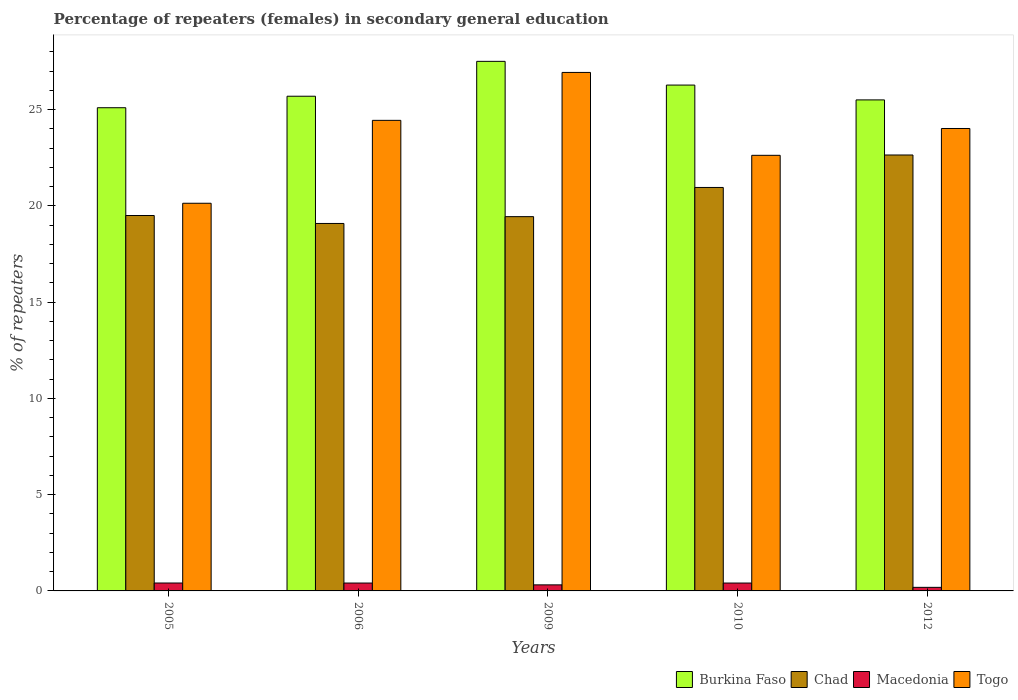How many different coloured bars are there?
Your answer should be compact. 4. How many groups of bars are there?
Give a very brief answer. 5. Are the number of bars per tick equal to the number of legend labels?
Keep it short and to the point. Yes. How many bars are there on the 3rd tick from the right?
Keep it short and to the point. 4. What is the label of the 2nd group of bars from the left?
Offer a terse response. 2006. What is the percentage of female repeaters in Macedonia in 2012?
Your answer should be compact. 0.19. Across all years, what is the maximum percentage of female repeaters in Macedonia?
Make the answer very short. 0.41. Across all years, what is the minimum percentage of female repeaters in Chad?
Provide a short and direct response. 19.09. In which year was the percentage of female repeaters in Togo maximum?
Keep it short and to the point. 2009. In which year was the percentage of female repeaters in Chad minimum?
Provide a succinct answer. 2006. What is the total percentage of female repeaters in Burkina Faso in the graph?
Your answer should be very brief. 130.07. What is the difference between the percentage of female repeaters in Macedonia in 2005 and that in 2006?
Your answer should be compact. 0. What is the difference between the percentage of female repeaters in Chad in 2010 and the percentage of female repeaters in Togo in 2009?
Provide a succinct answer. -5.98. What is the average percentage of female repeaters in Burkina Faso per year?
Provide a short and direct response. 26.01. In the year 2010, what is the difference between the percentage of female repeaters in Togo and percentage of female repeaters in Chad?
Offer a terse response. 1.67. In how many years, is the percentage of female repeaters in Chad greater than 25 %?
Your response must be concise. 0. What is the ratio of the percentage of female repeaters in Macedonia in 2005 to that in 2012?
Offer a terse response. 2.22. Is the percentage of female repeaters in Macedonia in 2009 less than that in 2010?
Offer a very short reply. Yes. Is the difference between the percentage of female repeaters in Togo in 2010 and 2012 greater than the difference between the percentage of female repeaters in Chad in 2010 and 2012?
Your answer should be compact. Yes. What is the difference between the highest and the second highest percentage of female repeaters in Chad?
Ensure brevity in your answer.  1.69. What is the difference between the highest and the lowest percentage of female repeaters in Chad?
Ensure brevity in your answer.  3.56. In how many years, is the percentage of female repeaters in Togo greater than the average percentage of female repeaters in Togo taken over all years?
Offer a terse response. 3. Is the sum of the percentage of female repeaters in Togo in 2005 and 2009 greater than the maximum percentage of female repeaters in Chad across all years?
Keep it short and to the point. Yes. Is it the case that in every year, the sum of the percentage of female repeaters in Burkina Faso and percentage of female repeaters in Macedonia is greater than the sum of percentage of female repeaters in Togo and percentage of female repeaters in Chad?
Offer a very short reply. No. What does the 3rd bar from the left in 2005 represents?
Provide a succinct answer. Macedonia. What does the 4th bar from the right in 2010 represents?
Ensure brevity in your answer.  Burkina Faso. Is it the case that in every year, the sum of the percentage of female repeaters in Togo and percentage of female repeaters in Burkina Faso is greater than the percentage of female repeaters in Macedonia?
Your response must be concise. Yes. How many years are there in the graph?
Your response must be concise. 5. Does the graph contain any zero values?
Keep it short and to the point. No. How are the legend labels stacked?
Offer a terse response. Horizontal. What is the title of the graph?
Your answer should be compact. Percentage of repeaters (females) in secondary general education. Does "East Asia (all income levels)" appear as one of the legend labels in the graph?
Keep it short and to the point. No. What is the label or title of the Y-axis?
Keep it short and to the point. % of repeaters. What is the % of repeaters of Burkina Faso in 2005?
Provide a succinct answer. 25.1. What is the % of repeaters of Chad in 2005?
Offer a terse response. 19.5. What is the % of repeaters of Macedonia in 2005?
Ensure brevity in your answer.  0.41. What is the % of repeaters of Togo in 2005?
Give a very brief answer. 20.13. What is the % of repeaters of Burkina Faso in 2006?
Offer a terse response. 25.69. What is the % of repeaters in Chad in 2006?
Keep it short and to the point. 19.09. What is the % of repeaters of Macedonia in 2006?
Keep it short and to the point. 0.41. What is the % of repeaters in Togo in 2006?
Provide a succinct answer. 24.44. What is the % of repeaters in Burkina Faso in 2009?
Make the answer very short. 27.5. What is the % of repeaters of Chad in 2009?
Your answer should be very brief. 19.44. What is the % of repeaters of Macedonia in 2009?
Offer a terse response. 0.31. What is the % of repeaters in Togo in 2009?
Offer a terse response. 26.93. What is the % of repeaters of Burkina Faso in 2010?
Provide a short and direct response. 26.27. What is the % of repeaters of Chad in 2010?
Offer a terse response. 20.95. What is the % of repeaters in Macedonia in 2010?
Ensure brevity in your answer.  0.41. What is the % of repeaters in Togo in 2010?
Make the answer very short. 22.62. What is the % of repeaters of Burkina Faso in 2012?
Provide a short and direct response. 25.5. What is the % of repeaters in Chad in 2012?
Your response must be concise. 22.64. What is the % of repeaters in Macedonia in 2012?
Offer a terse response. 0.19. What is the % of repeaters in Togo in 2012?
Offer a terse response. 24.02. Across all years, what is the maximum % of repeaters in Burkina Faso?
Make the answer very short. 27.5. Across all years, what is the maximum % of repeaters of Chad?
Your response must be concise. 22.64. Across all years, what is the maximum % of repeaters in Macedonia?
Provide a succinct answer. 0.41. Across all years, what is the maximum % of repeaters of Togo?
Make the answer very short. 26.93. Across all years, what is the minimum % of repeaters of Burkina Faso?
Offer a very short reply. 25.1. Across all years, what is the minimum % of repeaters in Chad?
Your answer should be compact. 19.09. Across all years, what is the minimum % of repeaters in Macedonia?
Give a very brief answer. 0.19. Across all years, what is the minimum % of repeaters in Togo?
Give a very brief answer. 20.13. What is the total % of repeaters in Burkina Faso in the graph?
Provide a succinct answer. 130.07. What is the total % of repeaters in Chad in the graph?
Your answer should be very brief. 101.62. What is the total % of repeaters of Macedonia in the graph?
Offer a terse response. 1.73. What is the total % of repeaters of Togo in the graph?
Provide a succinct answer. 118.15. What is the difference between the % of repeaters of Burkina Faso in 2005 and that in 2006?
Give a very brief answer. -0.6. What is the difference between the % of repeaters in Chad in 2005 and that in 2006?
Your answer should be very brief. 0.41. What is the difference between the % of repeaters of Macedonia in 2005 and that in 2006?
Give a very brief answer. 0. What is the difference between the % of repeaters of Togo in 2005 and that in 2006?
Your answer should be compact. -4.31. What is the difference between the % of repeaters of Burkina Faso in 2005 and that in 2009?
Offer a very short reply. -2.41. What is the difference between the % of repeaters of Chad in 2005 and that in 2009?
Your response must be concise. 0.06. What is the difference between the % of repeaters in Macedonia in 2005 and that in 2009?
Offer a terse response. 0.1. What is the difference between the % of repeaters in Togo in 2005 and that in 2009?
Your answer should be compact. -6.79. What is the difference between the % of repeaters of Burkina Faso in 2005 and that in 2010?
Give a very brief answer. -1.18. What is the difference between the % of repeaters of Chad in 2005 and that in 2010?
Provide a short and direct response. -1.46. What is the difference between the % of repeaters of Macedonia in 2005 and that in 2010?
Your response must be concise. 0. What is the difference between the % of repeaters in Togo in 2005 and that in 2010?
Keep it short and to the point. -2.49. What is the difference between the % of repeaters of Burkina Faso in 2005 and that in 2012?
Give a very brief answer. -0.41. What is the difference between the % of repeaters in Chad in 2005 and that in 2012?
Make the answer very short. -3.14. What is the difference between the % of repeaters in Macedonia in 2005 and that in 2012?
Provide a short and direct response. 0.23. What is the difference between the % of repeaters in Togo in 2005 and that in 2012?
Ensure brevity in your answer.  -3.88. What is the difference between the % of repeaters of Burkina Faso in 2006 and that in 2009?
Offer a terse response. -1.81. What is the difference between the % of repeaters in Chad in 2006 and that in 2009?
Provide a succinct answer. -0.35. What is the difference between the % of repeaters of Macedonia in 2006 and that in 2009?
Provide a succinct answer. 0.1. What is the difference between the % of repeaters in Togo in 2006 and that in 2009?
Give a very brief answer. -2.49. What is the difference between the % of repeaters of Burkina Faso in 2006 and that in 2010?
Make the answer very short. -0.58. What is the difference between the % of repeaters in Chad in 2006 and that in 2010?
Your answer should be compact. -1.87. What is the difference between the % of repeaters in Macedonia in 2006 and that in 2010?
Offer a terse response. 0. What is the difference between the % of repeaters in Togo in 2006 and that in 2010?
Make the answer very short. 1.82. What is the difference between the % of repeaters in Burkina Faso in 2006 and that in 2012?
Ensure brevity in your answer.  0.19. What is the difference between the % of repeaters of Chad in 2006 and that in 2012?
Offer a very short reply. -3.56. What is the difference between the % of repeaters of Macedonia in 2006 and that in 2012?
Your answer should be very brief. 0.22. What is the difference between the % of repeaters of Togo in 2006 and that in 2012?
Offer a very short reply. 0.42. What is the difference between the % of repeaters in Burkina Faso in 2009 and that in 2010?
Your response must be concise. 1.23. What is the difference between the % of repeaters of Chad in 2009 and that in 2010?
Provide a short and direct response. -1.52. What is the difference between the % of repeaters in Macedonia in 2009 and that in 2010?
Make the answer very short. -0.1. What is the difference between the % of repeaters in Togo in 2009 and that in 2010?
Give a very brief answer. 4.31. What is the difference between the % of repeaters in Burkina Faso in 2009 and that in 2012?
Provide a succinct answer. 2. What is the difference between the % of repeaters in Chad in 2009 and that in 2012?
Provide a short and direct response. -3.2. What is the difference between the % of repeaters in Macedonia in 2009 and that in 2012?
Your answer should be compact. 0.13. What is the difference between the % of repeaters of Togo in 2009 and that in 2012?
Provide a short and direct response. 2.91. What is the difference between the % of repeaters of Burkina Faso in 2010 and that in 2012?
Keep it short and to the point. 0.77. What is the difference between the % of repeaters in Chad in 2010 and that in 2012?
Your response must be concise. -1.69. What is the difference between the % of repeaters in Macedonia in 2010 and that in 2012?
Keep it short and to the point. 0.22. What is the difference between the % of repeaters in Togo in 2010 and that in 2012?
Make the answer very short. -1.39. What is the difference between the % of repeaters in Burkina Faso in 2005 and the % of repeaters in Chad in 2006?
Give a very brief answer. 6.01. What is the difference between the % of repeaters of Burkina Faso in 2005 and the % of repeaters of Macedonia in 2006?
Your answer should be very brief. 24.69. What is the difference between the % of repeaters in Burkina Faso in 2005 and the % of repeaters in Togo in 2006?
Your answer should be very brief. 0.66. What is the difference between the % of repeaters in Chad in 2005 and the % of repeaters in Macedonia in 2006?
Offer a terse response. 19.09. What is the difference between the % of repeaters in Chad in 2005 and the % of repeaters in Togo in 2006?
Make the answer very short. -4.94. What is the difference between the % of repeaters of Macedonia in 2005 and the % of repeaters of Togo in 2006?
Keep it short and to the point. -24.03. What is the difference between the % of repeaters in Burkina Faso in 2005 and the % of repeaters in Chad in 2009?
Offer a very short reply. 5.66. What is the difference between the % of repeaters of Burkina Faso in 2005 and the % of repeaters of Macedonia in 2009?
Provide a short and direct response. 24.78. What is the difference between the % of repeaters in Burkina Faso in 2005 and the % of repeaters in Togo in 2009?
Your answer should be very brief. -1.83. What is the difference between the % of repeaters in Chad in 2005 and the % of repeaters in Macedonia in 2009?
Give a very brief answer. 19.18. What is the difference between the % of repeaters of Chad in 2005 and the % of repeaters of Togo in 2009?
Provide a short and direct response. -7.43. What is the difference between the % of repeaters in Macedonia in 2005 and the % of repeaters in Togo in 2009?
Give a very brief answer. -26.52. What is the difference between the % of repeaters of Burkina Faso in 2005 and the % of repeaters of Chad in 2010?
Your answer should be compact. 4.14. What is the difference between the % of repeaters of Burkina Faso in 2005 and the % of repeaters of Macedonia in 2010?
Give a very brief answer. 24.69. What is the difference between the % of repeaters in Burkina Faso in 2005 and the % of repeaters in Togo in 2010?
Offer a very short reply. 2.47. What is the difference between the % of repeaters in Chad in 2005 and the % of repeaters in Macedonia in 2010?
Keep it short and to the point. 19.09. What is the difference between the % of repeaters of Chad in 2005 and the % of repeaters of Togo in 2010?
Make the answer very short. -3.13. What is the difference between the % of repeaters in Macedonia in 2005 and the % of repeaters in Togo in 2010?
Make the answer very short. -22.21. What is the difference between the % of repeaters of Burkina Faso in 2005 and the % of repeaters of Chad in 2012?
Your answer should be very brief. 2.45. What is the difference between the % of repeaters in Burkina Faso in 2005 and the % of repeaters in Macedonia in 2012?
Your answer should be compact. 24.91. What is the difference between the % of repeaters in Burkina Faso in 2005 and the % of repeaters in Togo in 2012?
Your answer should be compact. 1.08. What is the difference between the % of repeaters in Chad in 2005 and the % of repeaters in Macedonia in 2012?
Your answer should be very brief. 19.31. What is the difference between the % of repeaters of Chad in 2005 and the % of repeaters of Togo in 2012?
Your response must be concise. -4.52. What is the difference between the % of repeaters of Macedonia in 2005 and the % of repeaters of Togo in 2012?
Ensure brevity in your answer.  -23.61. What is the difference between the % of repeaters in Burkina Faso in 2006 and the % of repeaters in Chad in 2009?
Ensure brevity in your answer.  6.25. What is the difference between the % of repeaters of Burkina Faso in 2006 and the % of repeaters of Macedonia in 2009?
Your answer should be very brief. 25.38. What is the difference between the % of repeaters of Burkina Faso in 2006 and the % of repeaters of Togo in 2009?
Give a very brief answer. -1.24. What is the difference between the % of repeaters of Chad in 2006 and the % of repeaters of Macedonia in 2009?
Offer a very short reply. 18.77. What is the difference between the % of repeaters in Chad in 2006 and the % of repeaters in Togo in 2009?
Provide a short and direct response. -7.84. What is the difference between the % of repeaters of Macedonia in 2006 and the % of repeaters of Togo in 2009?
Provide a succinct answer. -26.52. What is the difference between the % of repeaters in Burkina Faso in 2006 and the % of repeaters in Chad in 2010?
Offer a very short reply. 4.74. What is the difference between the % of repeaters in Burkina Faso in 2006 and the % of repeaters in Macedonia in 2010?
Your answer should be very brief. 25.28. What is the difference between the % of repeaters in Burkina Faso in 2006 and the % of repeaters in Togo in 2010?
Keep it short and to the point. 3.07. What is the difference between the % of repeaters in Chad in 2006 and the % of repeaters in Macedonia in 2010?
Keep it short and to the point. 18.68. What is the difference between the % of repeaters of Chad in 2006 and the % of repeaters of Togo in 2010?
Your response must be concise. -3.54. What is the difference between the % of repeaters in Macedonia in 2006 and the % of repeaters in Togo in 2010?
Ensure brevity in your answer.  -22.21. What is the difference between the % of repeaters in Burkina Faso in 2006 and the % of repeaters in Chad in 2012?
Your answer should be very brief. 3.05. What is the difference between the % of repeaters in Burkina Faso in 2006 and the % of repeaters in Macedonia in 2012?
Your answer should be very brief. 25.51. What is the difference between the % of repeaters in Burkina Faso in 2006 and the % of repeaters in Togo in 2012?
Provide a succinct answer. 1.68. What is the difference between the % of repeaters in Chad in 2006 and the % of repeaters in Macedonia in 2012?
Give a very brief answer. 18.9. What is the difference between the % of repeaters of Chad in 2006 and the % of repeaters of Togo in 2012?
Your response must be concise. -4.93. What is the difference between the % of repeaters of Macedonia in 2006 and the % of repeaters of Togo in 2012?
Provide a short and direct response. -23.61. What is the difference between the % of repeaters in Burkina Faso in 2009 and the % of repeaters in Chad in 2010?
Ensure brevity in your answer.  6.55. What is the difference between the % of repeaters of Burkina Faso in 2009 and the % of repeaters of Macedonia in 2010?
Your response must be concise. 27.1. What is the difference between the % of repeaters of Burkina Faso in 2009 and the % of repeaters of Togo in 2010?
Give a very brief answer. 4.88. What is the difference between the % of repeaters of Chad in 2009 and the % of repeaters of Macedonia in 2010?
Provide a succinct answer. 19.03. What is the difference between the % of repeaters in Chad in 2009 and the % of repeaters in Togo in 2010?
Provide a short and direct response. -3.19. What is the difference between the % of repeaters in Macedonia in 2009 and the % of repeaters in Togo in 2010?
Your answer should be compact. -22.31. What is the difference between the % of repeaters in Burkina Faso in 2009 and the % of repeaters in Chad in 2012?
Your answer should be very brief. 4.86. What is the difference between the % of repeaters in Burkina Faso in 2009 and the % of repeaters in Macedonia in 2012?
Make the answer very short. 27.32. What is the difference between the % of repeaters in Burkina Faso in 2009 and the % of repeaters in Togo in 2012?
Provide a short and direct response. 3.49. What is the difference between the % of repeaters of Chad in 2009 and the % of repeaters of Macedonia in 2012?
Give a very brief answer. 19.25. What is the difference between the % of repeaters in Chad in 2009 and the % of repeaters in Togo in 2012?
Your response must be concise. -4.58. What is the difference between the % of repeaters in Macedonia in 2009 and the % of repeaters in Togo in 2012?
Provide a short and direct response. -23.7. What is the difference between the % of repeaters in Burkina Faso in 2010 and the % of repeaters in Chad in 2012?
Ensure brevity in your answer.  3.63. What is the difference between the % of repeaters of Burkina Faso in 2010 and the % of repeaters of Macedonia in 2012?
Keep it short and to the point. 26.09. What is the difference between the % of repeaters of Burkina Faso in 2010 and the % of repeaters of Togo in 2012?
Provide a succinct answer. 2.26. What is the difference between the % of repeaters in Chad in 2010 and the % of repeaters in Macedonia in 2012?
Your answer should be compact. 20.77. What is the difference between the % of repeaters in Chad in 2010 and the % of repeaters in Togo in 2012?
Your answer should be compact. -3.06. What is the difference between the % of repeaters in Macedonia in 2010 and the % of repeaters in Togo in 2012?
Your answer should be very brief. -23.61. What is the average % of repeaters in Burkina Faso per year?
Your answer should be compact. 26.01. What is the average % of repeaters in Chad per year?
Provide a succinct answer. 20.32. What is the average % of repeaters in Macedonia per year?
Keep it short and to the point. 0.35. What is the average % of repeaters in Togo per year?
Your response must be concise. 23.63. In the year 2005, what is the difference between the % of repeaters of Burkina Faso and % of repeaters of Chad?
Your response must be concise. 5.6. In the year 2005, what is the difference between the % of repeaters of Burkina Faso and % of repeaters of Macedonia?
Provide a short and direct response. 24.69. In the year 2005, what is the difference between the % of repeaters of Burkina Faso and % of repeaters of Togo?
Keep it short and to the point. 4.96. In the year 2005, what is the difference between the % of repeaters of Chad and % of repeaters of Macedonia?
Provide a succinct answer. 19.09. In the year 2005, what is the difference between the % of repeaters in Chad and % of repeaters in Togo?
Make the answer very short. -0.64. In the year 2005, what is the difference between the % of repeaters in Macedonia and % of repeaters in Togo?
Provide a succinct answer. -19.72. In the year 2006, what is the difference between the % of repeaters of Burkina Faso and % of repeaters of Chad?
Offer a very short reply. 6.61. In the year 2006, what is the difference between the % of repeaters of Burkina Faso and % of repeaters of Macedonia?
Ensure brevity in your answer.  25.28. In the year 2006, what is the difference between the % of repeaters of Burkina Faso and % of repeaters of Togo?
Provide a succinct answer. 1.25. In the year 2006, what is the difference between the % of repeaters of Chad and % of repeaters of Macedonia?
Provide a succinct answer. 18.68. In the year 2006, what is the difference between the % of repeaters of Chad and % of repeaters of Togo?
Provide a short and direct response. -5.36. In the year 2006, what is the difference between the % of repeaters of Macedonia and % of repeaters of Togo?
Offer a terse response. -24.03. In the year 2009, what is the difference between the % of repeaters of Burkina Faso and % of repeaters of Chad?
Provide a succinct answer. 8.07. In the year 2009, what is the difference between the % of repeaters of Burkina Faso and % of repeaters of Macedonia?
Your answer should be compact. 27.19. In the year 2009, what is the difference between the % of repeaters of Burkina Faso and % of repeaters of Togo?
Make the answer very short. 0.57. In the year 2009, what is the difference between the % of repeaters in Chad and % of repeaters in Macedonia?
Your response must be concise. 19.12. In the year 2009, what is the difference between the % of repeaters of Chad and % of repeaters of Togo?
Offer a terse response. -7.49. In the year 2009, what is the difference between the % of repeaters in Macedonia and % of repeaters in Togo?
Keep it short and to the point. -26.62. In the year 2010, what is the difference between the % of repeaters of Burkina Faso and % of repeaters of Chad?
Your response must be concise. 5.32. In the year 2010, what is the difference between the % of repeaters of Burkina Faso and % of repeaters of Macedonia?
Keep it short and to the point. 25.86. In the year 2010, what is the difference between the % of repeaters in Burkina Faso and % of repeaters in Togo?
Provide a short and direct response. 3.65. In the year 2010, what is the difference between the % of repeaters in Chad and % of repeaters in Macedonia?
Your answer should be compact. 20.55. In the year 2010, what is the difference between the % of repeaters in Chad and % of repeaters in Togo?
Ensure brevity in your answer.  -1.67. In the year 2010, what is the difference between the % of repeaters of Macedonia and % of repeaters of Togo?
Make the answer very short. -22.22. In the year 2012, what is the difference between the % of repeaters of Burkina Faso and % of repeaters of Chad?
Provide a succinct answer. 2.86. In the year 2012, what is the difference between the % of repeaters of Burkina Faso and % of repeaters of Macedonia?
Your answer should be very brief. 25.32. In the year 2012, what is the difference between the % of repeaters of Burkina Faso and % of repeaters of Togo?
Keep it short and to the point. 1.49. In the year 2012, what is the difference between the % of repeaters of Chad and % of repeaters of Macedonia?
Make the answer very short. 22.46. In the year 2012, what is the difference between the % of repeaters of Chad and % of repeaters of Togo?
Offer a terse response. -1.38. In the year 2012, what is the difference between the % of repeaters in Macedonia and % of repeaters in Togo?
Make the answer very short. -23.83. What is the ratio of the % of repeaters of Burkina Faso in 2005 to that in 2006?
Offer a very short reply. 0.98. What is the ratio of the % of repeaters in Chad in 2005 to that in 2006?
Your answer should be compact. 1.02. What is the ratio of the % of repeaters of Togo in 2005 to that in 2006?
Offer a terse response. 0.82. What is the ratio of the % of repeaters of Burkina Faso in 2005 to that in 2009?
Keep it short and to the point. 0.91. What is the ratio of the % of repeaters of Macedonia in 2005 to that in 2009?
Ensure brevity in your answer.  1.31. What is the ratio of the % of repeaters in Togo in 2005 to that in 2009?
Your answer should be very brief. 0.75. What is the ratio of the % of repeaters in Burkina Faso in 2005 to that in 2010?
Your answer should be compact. 0.96. What is the ratio of the % of repeaters in Chad in 2005 to that in 2010?
Ensure brevity in your answer.  0.93. What is the ratio of the % of repeaters of Macedonia in 2005 to that in 2010?
Provide a short and direct response. 1. What is the ratio of the % of repeaters in Togo in 2005 to that in 2010?
Offer a very short reply. 0.89. What is the ratio of the % of repeaters in Burkina Faso in 2005 to that in 2012?
Ensure brevity in your answer.  0.98. What is the ratio of the % of repeaters in Chad in 2005 to that in 2012?
Your response must be concise. 0.86. What is the ratio of the % of repeaters of Macedonia in 2005 to that in 2012?
Your response must be concise. 2.22. What is the ratio of the % of repeaters in Togo in 2005 to that in 2012?
Provide a short and direct response. 0.84. What is the ratio of the % of repeaters of Burkina Faso in 2006 to that in 2009?
Your response must be concise. 0.93. What is the ratio of the % of repeaters of Chad in 2006 to that in 2009?
Your response must be concise. 0.98. What is the ratio of the % of repeaters of Macedonia in 2006 to that in 2009?
Your answer should be very brief. 1.3. What is the ratio of the % of repeaters in Togo in 2006 to that in 2009?
Make the answer very short. 0.91. What is the ratio of the % of repeaters in Burkina Faso in 2006 to that in 2010?
Provide a short and direct response. 0.98. What is the ratio of the % of repeaters of Chad in 2006 to that in 2010?
Ensure brevity in your answer.  0.91. What is the ratio of the % of repeaters in Macedonia in 2006 to that in 2010?
Make the answer very short. 1. What is the ratio of the % of repeaters of Togo in 2006 to that in 2010?
Give a very brief answer. 1.08. What is the ratio of the % of repeaters in Burkina Faso in 2006 to that in 2012?
Ensure brevity in your answer.  1.01. What is the ratio of the % of repeaters in Chad in 2006 to that in 2012?
Your answer should be very brief. 0.84. What is the ratio of the % of repeaters of Macedonia in 2006 to that in 2012?
Your response must be concise. 2.21. What is the ratio of the % of repeaters in Togo in 2006 to that in 2012?
Make the answer very short. 1.02. What is the ratio of the % of repeaters in Burkina Faso in 2009 to that in 2010?
Your response must be concise. 1.05. What is the ratio of the % of repeaters in Chad in 2009 to that in 2010?
Provide a short and direct response. 0.93. What is the ratio of the % of repeaters in Macedonia in 2009 to that in 2010?
Make the answer very short. 0.77. What is the ratio of the % of repeaters in Togo in 2009 to that in 2010?
Provide a succinct answer. 1.19. What is the ratio of the % of repeaters of Burkina Faso in 2009 to that in 2012?
Your answer should be very brief. 1.08. What is the ratio of the % of repeaters in Chad in 2009 to that in 2012?
Your answer should be very brief. 0.86. What is the ratio of the % of repeaters in Macedonia in 2009 to that in 2012?
Keep it short and to the point. 1.7. What is the ratio of the % of repeaters in Togo in 2009 to that in 2012?
Offer a very short reply. 1.12. What is the ratio of the % of repeaters of Burkina Faso in 2010 to that in 2012?
Provide a succinct answer. 1.03. What is the ratio of the % of repeaters of Chad in 2010 to that in 2012?
Provide a succinct answer. 0.93. What is the ratio of the % of repeaters of Macedonia in 2010 to that in 2012?
Your answer should be compact. 2.21. What is the ratio of the % of repeaters in Togo in 2010 to that in 2012?
Offer a very short reply. 0.94. What is the difference between the highest and the second highest % of repeaters in Burkina Faso?
Ensure brevity in your answer.  1.23. What is the difference between the highest and the second highest % of repeaters of Chad?
Make the answer very short. 1.69. What is the difference between the highest and the second highest % of repeaters in Macedonia?
Make the answer very short. 0. What is the difference between the highest and the second highest % of repeaters of Togo?
Provide a short and direct response. 2.49. What is the difference between the highest and the lowest % of repeaters of Burkina Faso?
Your response must be concise. 2.41. What is the difference between the highest and the lowest % of repeaters of Chad?
Offer a very short reply. 3.56. What is the difference between the highest and the lowest % of repeaters in Macedonia?
Offer a very short reply. 0.23. What is the difference between the highest and the lowest % of repeaters in Togo?
Your answer should be compact. 6.79. 